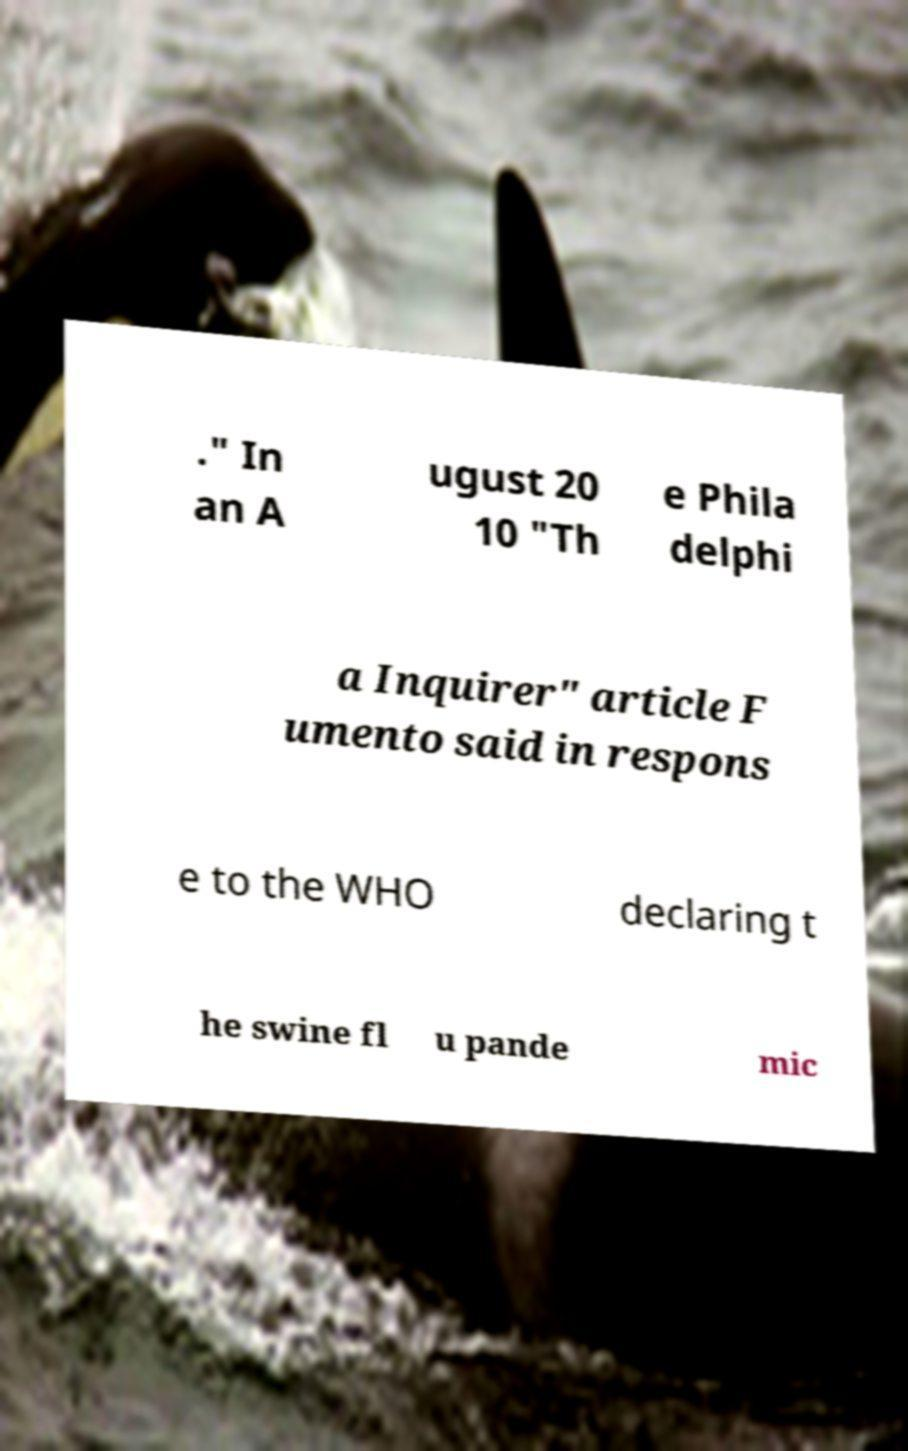Can you accurately transcribe the text from the provided image for me? ." In an A ugust 20 10 "Th e Phila delphi a Inquirer" article F umento said in respons e to the WHO declaring t he swine fl u pande mic 